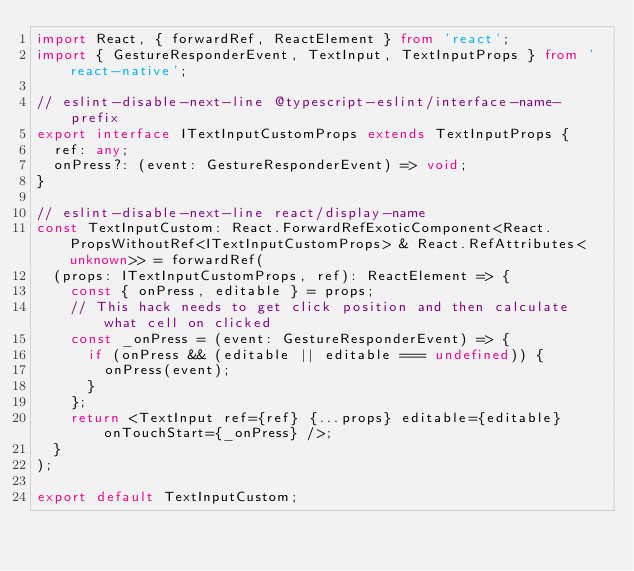<code> <loc_0><loc_0><loc_500><loc_500><_TypeScript_>import React, { forwardRef, ReactElement } from 'react';
import { GestureResponderEvent, TextInput, TextInputProps } from 'react-native';

// eslint-disable-next-line @typescript-eslint/interface-name-prefix
export interface ITextInputCustomProps extends TextInputProps {
  ref: any;
  onPress?: (event: GestureResponderEvent) => void;
}

// eslint-disable-next-line react/display-name
const TextInputCustom: React.ForwardRefExoticComponent<React.PropsWithoutRef<ITextInputCustomProps> & React.RefAttributes<unknown>> = forwardRef(
  (props: ITextInputCustomProps, ref): ReactElement => {
    const { onPress, editable } = props;
    // This hack needs to get click position and then calculate what cell on clicked
    const _onPress = (event: GestureResponderEvent) => {
      if (onPress && (editable || editable === undefined)) {
        onPress(event);
      }
    };
    return <TextInput ref={ref} {...props} editable={editable} onTouchStart={_onPress} />;
  }
);

export default TextInputCustom;
</code> 